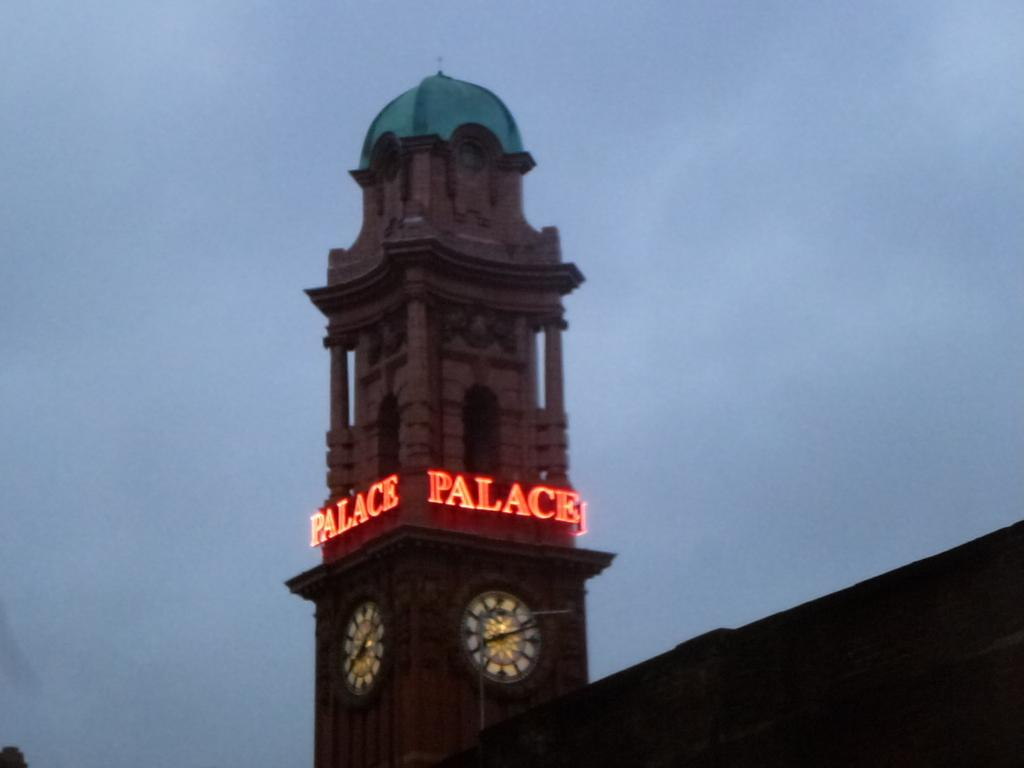<image>
Write a terse but informative summary of the picture. A tall clock tower says Palace on it in red lights. 